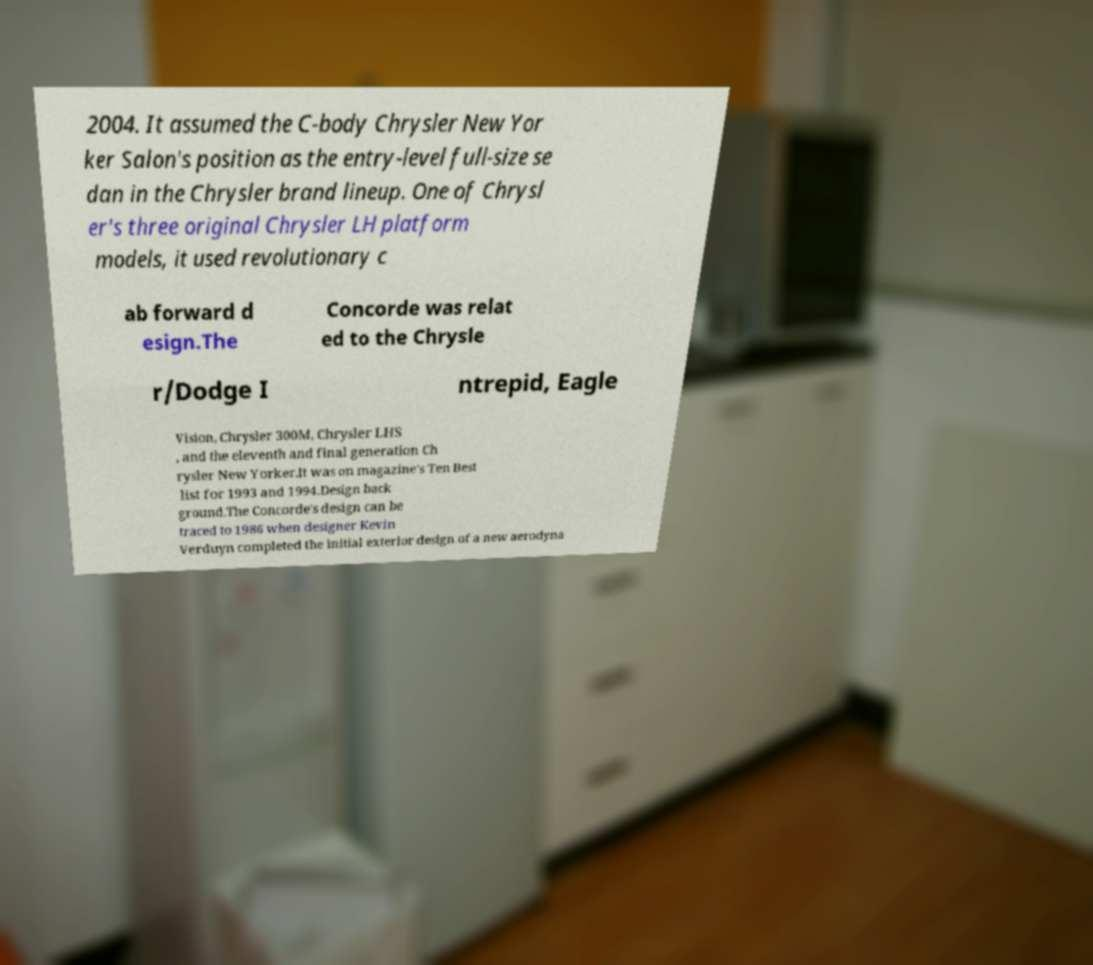Please read and relay the text visible in this image. What does it say? 2004. It assumed the C-body Chrysler New Yor ker Salon's position as the entry-level full-size se dan in the Chrysler brand lineup. One of Chrysl er's three original Chrysler LH platform models, it used revolutionary c ab forward d esign.The Concorde was relat ed to the Chrysle r/Dodge I ntrepid, Eagle Vision, Chrysler 300M, Chrysler LHS , and the eleventh and final generation Ch rysler New Yorker.It was on magazine's Ten Best list for 1993 and 1994.Design back ground.The Concorde's design can be traced to 1986 when designer Kevin Verduyn completed the initial exterior design of a new aerodyna 